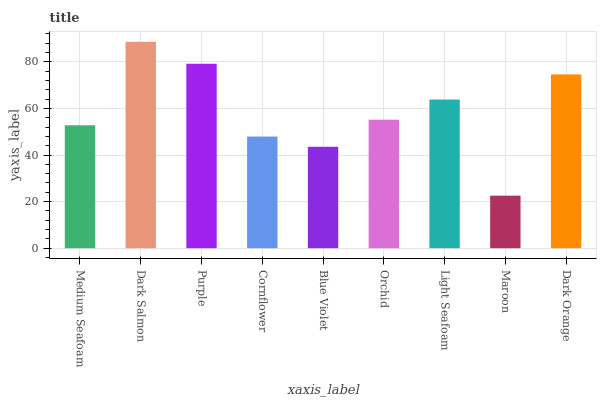Is Maroon the minimum?
Answer yes or no. Yes. Is Dark Salmon the maximum?
Answer yes or no. Yes. Is Purple the minimum?
Answer yes or no. No. Is Purple the maximum?
Answer yes or no. No. Is Dark Salmon greater than Purple?
Answer yes or no. Yes. Is Purple less than Dark Salmon?
Answer yes or no. Yes. Is Purple greater than Dark Salmon?
Answer yes or no. No. Is Dark Salmon less than Purple?
Answer yes or no. No. Is Orchid the high median?
Answer yes or no. Yes. Is Orchid the low median?
Answer yes or no. Yes. Is Medium Seafoam the high median?
Answer yes or no. No. Is Medium Seafoam the low median?
Answer yes or no. No. 